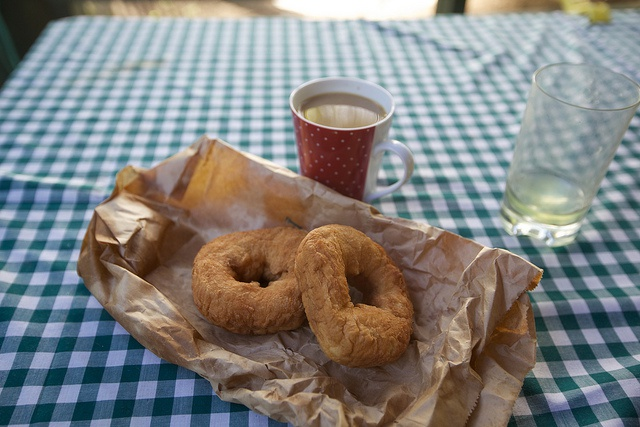Describe the objects in this image and their specific colors. I can see dining table in black, darkgray, lightgray, and gray tones, cup in black, darkgray, gray, lightgray, and beige tones, donut in black, brown, maroon, and gray tones, cup in black, maroon, darkgray, and gray tones, and donut in black, gray, brown, and maroon tones in this image. 